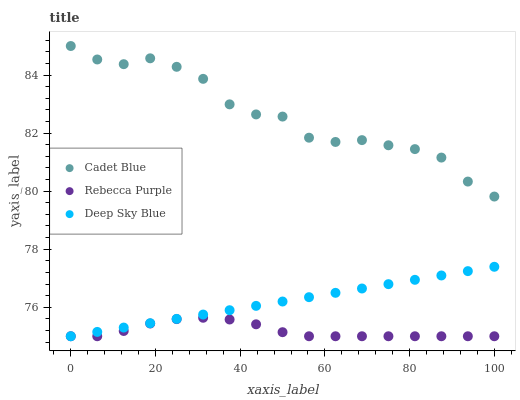Does Rebecca Purple have the minimum area under the curve?
Answer yes or no. Yes. Does Cadet Blue have the maximum area under the curve?
Answer yes or no. Yes. Does Deep Sky Blue have the minimum area under the curve?
Answer yes or no. No. Does Deep Sky Blue have the maximum area under the curve?
Answer yes or no. No. Is Deep Sky Blue the smoothest?
Answer yes or no. Yes. Is Cadet Blue the roughest?
Answer yes or no. Yes. Is Rebecca Purple the smoothest?
Answer yes or no. No. Is Rebecca Purple the roughest?
Answer yes or no. No. Does Rebecca Purple have the lowest value?
Answer yes or no. Yes. Does Cadet Blue have the highest value?
Answer yes or no. Yes. Does Deep Sky Blue have the highest value?
Answer yes or no. No. Is Deep Sky Blue less than Cadet Blue?
Answer yes or no. Yes. Is Cadet Blue greater than Rebecca Purple?
Answer yes or no. Yes. Does Deep Sky Blue intersect Rebecca Purple?
Answer yes or no. Yes. Is Deep Sky Blue less than Rebecca Purple?
Answer yes or no. No. Is Deep Sky Blue greater than Rebecca Purple?
Answer yes or no. No. Does Deep Sky Blue intersect Cadet Blue?
Answer yes or no. No. 